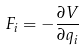Convert formula to latex. <formula><loc_0><loc_0><loc_500><loc_500>F _ { i } = - \frac { \partial V } { \partial q _ { i } }</formula> 